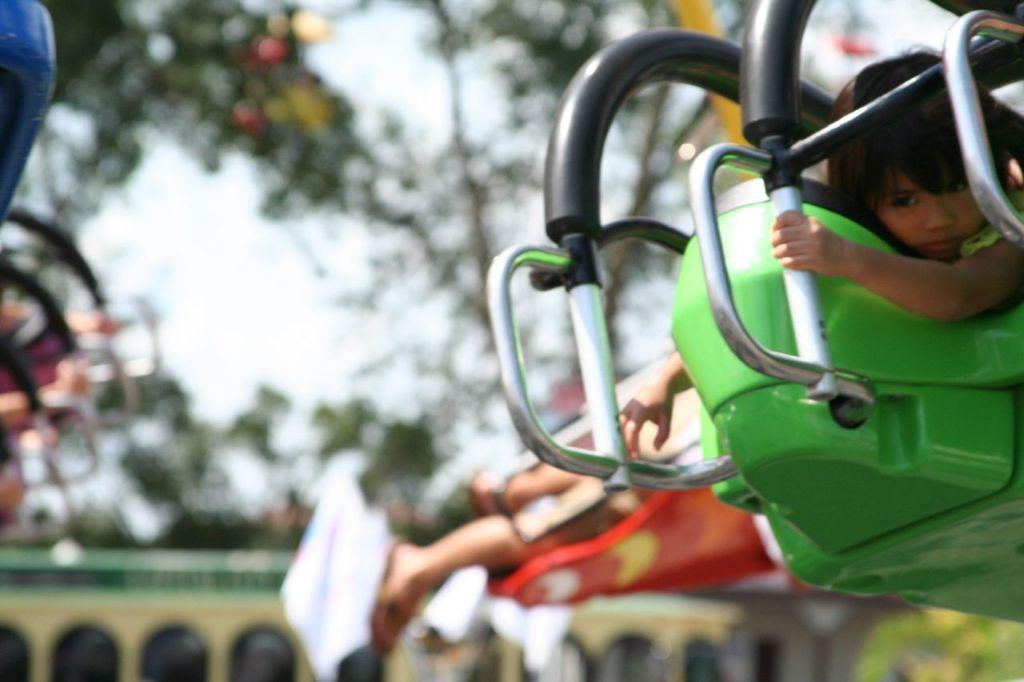What is the main subject in the foreground of the image? There is a kids amusement ride in the foreground of the image. Can you describe the background of the image? The background of the image is blurred. What type of jeans can be seen hanging from the amusement ride in the image? There are no jeans present in the image; it features a kids amusement ride in the foreground and a blurred background. 